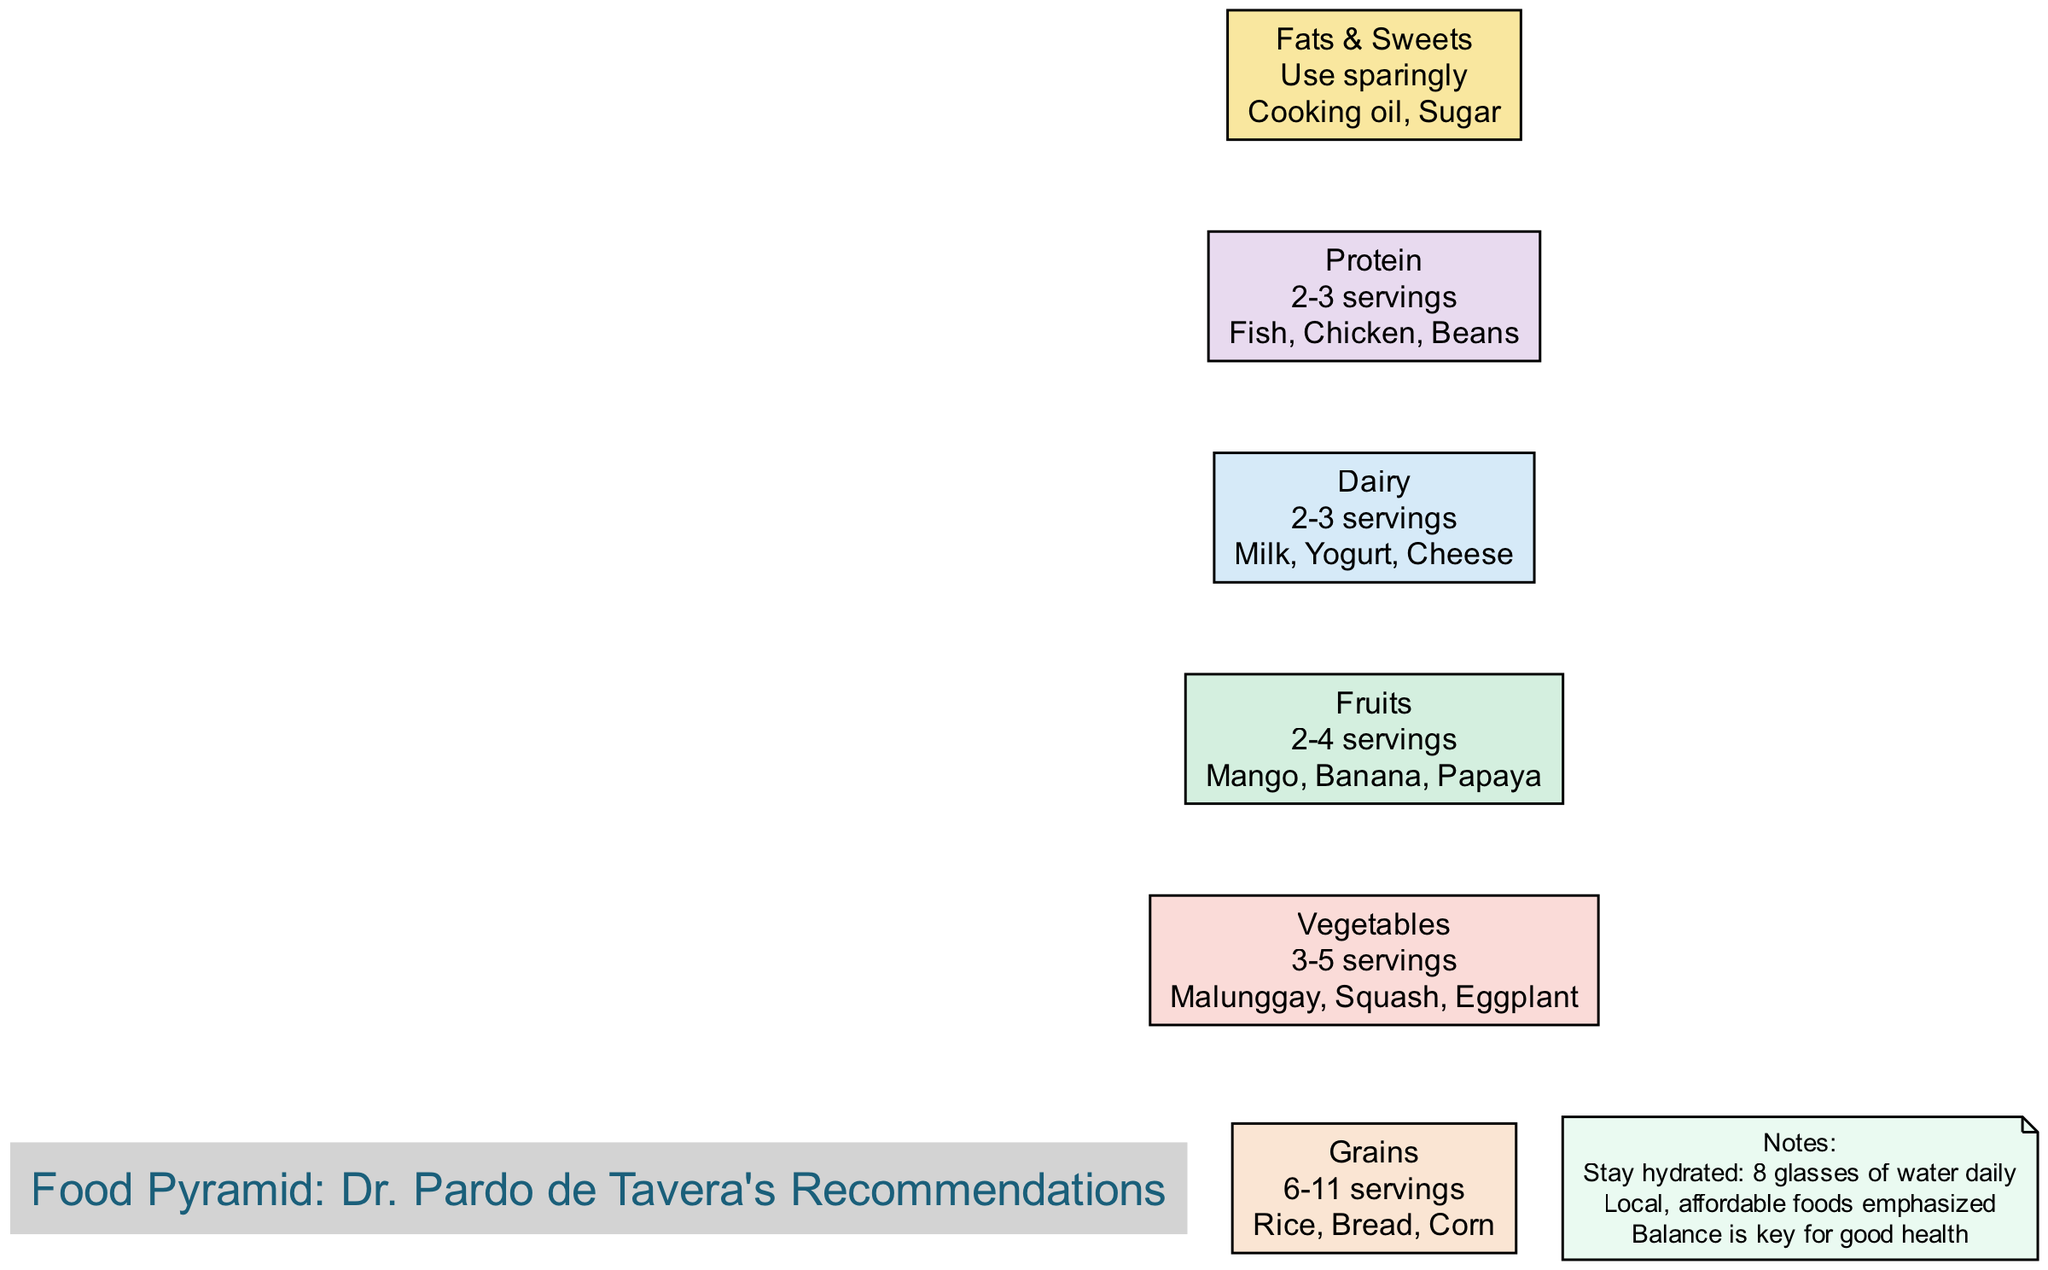What is the recommended daily servings for Vegetables? In the diagram under the "Vegetables" section, it states the recommended daily servings for vegetables is "3-5 servings."
Answer: 3-5 servings Which food group is recommended to be used sparingly? The diagram indicates in the "Fats & Sweets" section that these foods should be "Used sparingly."
Answer: Use sparingly How many examples of grains are provided in the diagram? In the "Grains" section, three examples are given: "Rice," "Bread," and "Corn," so we count three examples.
Answer: 3 What food categories fall under the Dairy section? The "Dairy" section lists three examples: "Milk," "Yogurt," and "Cheese," hence these are the food categories within that section.
Answer: Milk, Yogurt, Cheese How many servings of Protein are recommended? Looking at the "Protein" section, it specifies the recommended servings are "2-3 servings."
Answer: 2-3 servings What is emphasized in the notes regarding hydration? The notes section mentions to "Stay hydrated: 8 glasses of water daily," which clearly states the emphasis on hydration.
Answer: 8 glasses of water What examples of fruits are listed in the diagram? The 'Fruits' section shows three examples: "Mango," "Banana," and "Papaya," which are the listed examples of fruits.
Answer: Mango, Banana, Papaya Which group has the highest number of recommended servings? The "Grains" section has the highest range of recommended servings listed as "6-11 servings," which is more than any other food group.
Answer: 6-11 servings What are the key principles stated in the notes? The notes emphasize "Local, affordable foods" and "Balance is key for good health," which are important principles mentioned.
Answer: Local, affordable foods; Balance is key for good health 